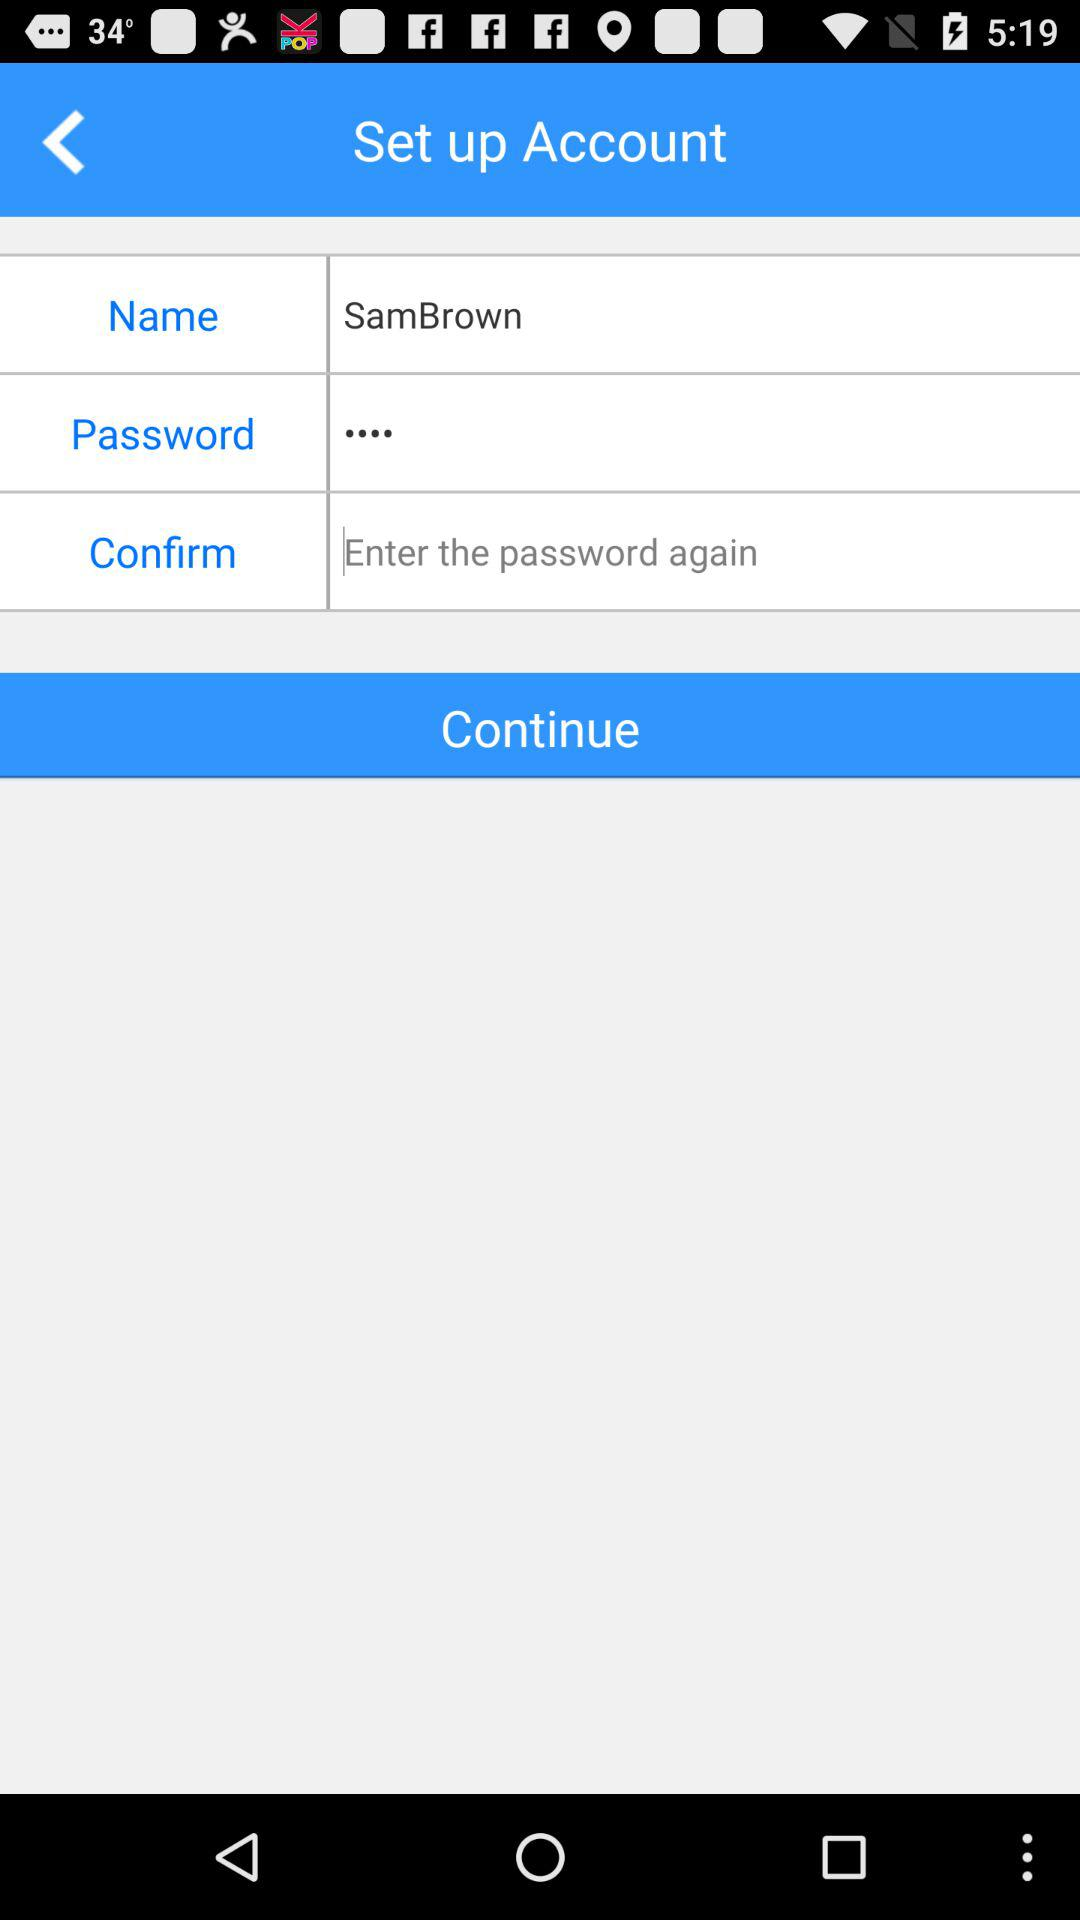What is the name? The name is Sam Brown. 